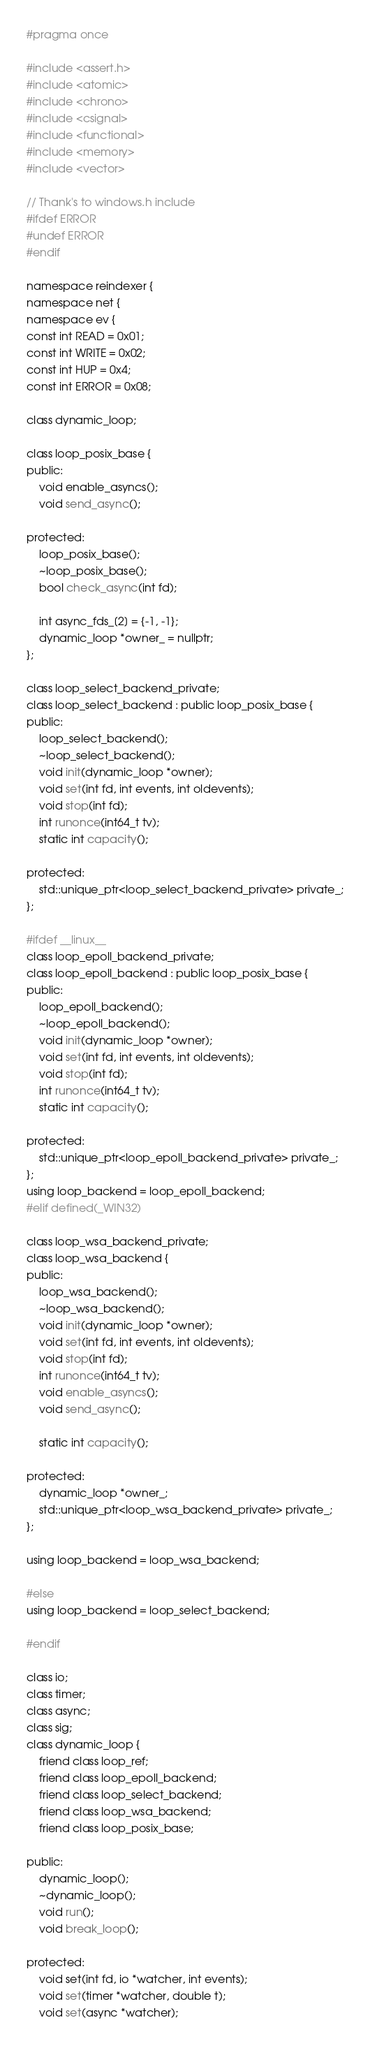<code> <loc_0><loc_0><loc_500><loc_500><_C_>#pragma once

#include <assert.h>
#include <atomic>
#include <chrono>
#include <csignal>
#include <functional>
#include <memory>
#include <vector>

// Thank's to windows.h include
#ifdef ERROR
#undef ERROR
#endif

namespace reindexer {
namespace net {
namespace ev {
const int READ = 0x01;
const int WRITE = 0x02;
const int HUP = 0x4;
const int ERROR = 0x08;

class dynamic_loop;

class loop_posix_base {
public:
	void enable_asyncs();
	void send_async();

protected:
	loop_posix_base();
	~loop_posix_base();
	bool check_async(int fd);

	int async_fds_[2] = {-1, -1};
	dynamic_loop *owner_ = nullptr;
};

class loop_select_backend_private;
class loop_select_backend : public loop_posix_base {
public:
	loop_select_backend();
	~loop_select_backend();
	void init(dynamic_loop *owner);
	void set(int fd, int events, int oldevents);
	void stop(int fd);
	int runonce(int64_t tv);
	static int capacity();

protected:
	std::unique_ptr<loop_select_backend_private> private_;
};

#ifdef __linux__
class loop_epoll_backend_private;
class loop_epoll_backend : public loop_posix_base {
public:
	loop_epoll_backend();
	~loop_epoll_backend();
	void init(dynamic_loop *owner);
	void set(int fd, int events, int oldevents);
	void stop(int fd);
	int runonce(int64_t tv);
	static int capacity();

protected:
	std::unique_ptr<loop_epoll_backend_private> private_;
};
using loop_backend = loop_epoll_backend;
#elif defined(_WIN32)

class loop_wsa_backend_private;
class loop_wsa_backend {
public:
	loop_wsa_backend();
	~loop_wsa_backend();
	void init(dynamic_loop *owner);
	void set(int fd, int events, int oldevents);
	void stop(int fd);
	int runonce(int64_t tv);
	void enable_asyncs();
	void send_async();

	static int capacity();

protected:
	dynamic_loop *owner_;
	std::unique_ptr<loop_wsa_backend_private> private_;
};

using loop_backend = loop_wsa_backend;

#else
using loop_backend = loop_select_backend;

#endif

class io;
class timer;
class async;
class sig;
class dynamic_loop {
	friend class loop_ref;
	friend class loop_epoll_backend;
	friend class loop_select_backend;
	friend class loop_wsa_backend;
	friend class loop_posix_base;

public:
	dynamic_loop();
	~dynamic_loop();
	void run();
	void break_loop();

protected:
	void set(int fd, io *watcher, int events);
	void set(timer *watcher, double t);
	void set(async *watcher);</code> 